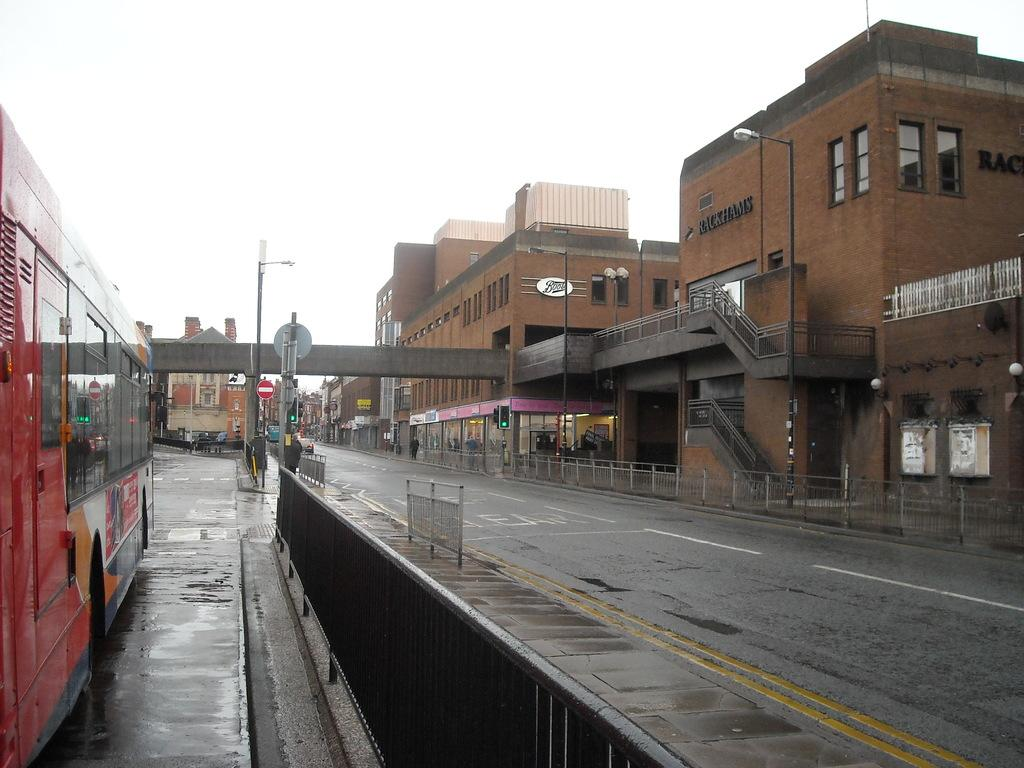<image>
Share a concise interpretation of the image provided. a street with only a red bus and brick buildings with one labeled Rackhams 